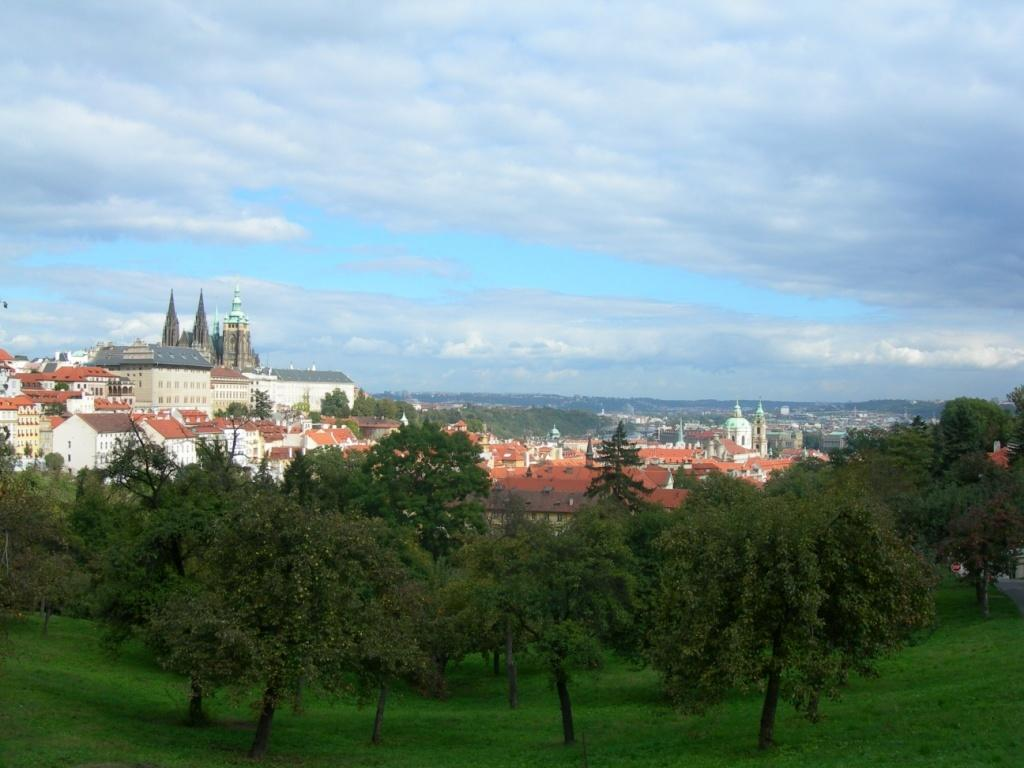What type of location is shown in the image? The image depicts a city. What structures can be seen in the city? There are buildings in the image. Are there any natural elements present in the city? Yes, there are trees in the image. What can be seen in the sky in the image? The sky is visible at the top of the image, and there are clouds in the sky. What is the ground surface like in the image? Grass is present at the bottom of the image. What type of rhythm can be heard coming from the buildings in the image? There is no sound or rhythm present in the image; it is a still picture of a city. 